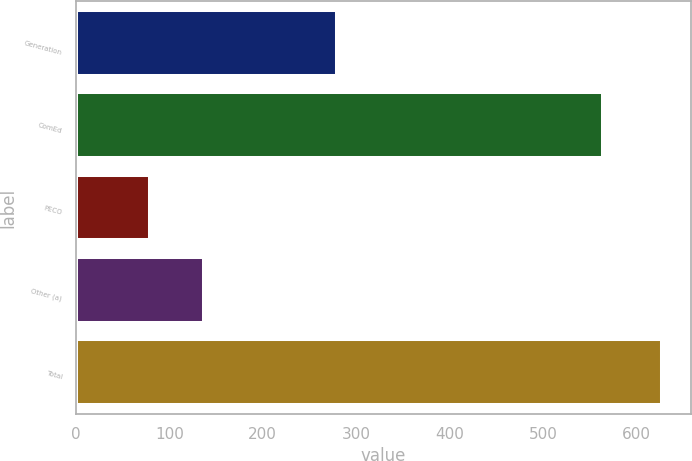Convert chart to OTSL. <chart><loc_0><loc_0><loc_500><loc_500><bar_chart><fcel>Generation<fcel>ComEd<fcel>PECO<fcel>Other (a)<fcel>Total<nl><fcel>279<fcel>564<fcel>79<fcel>137<fcel>627<nl></chart> 